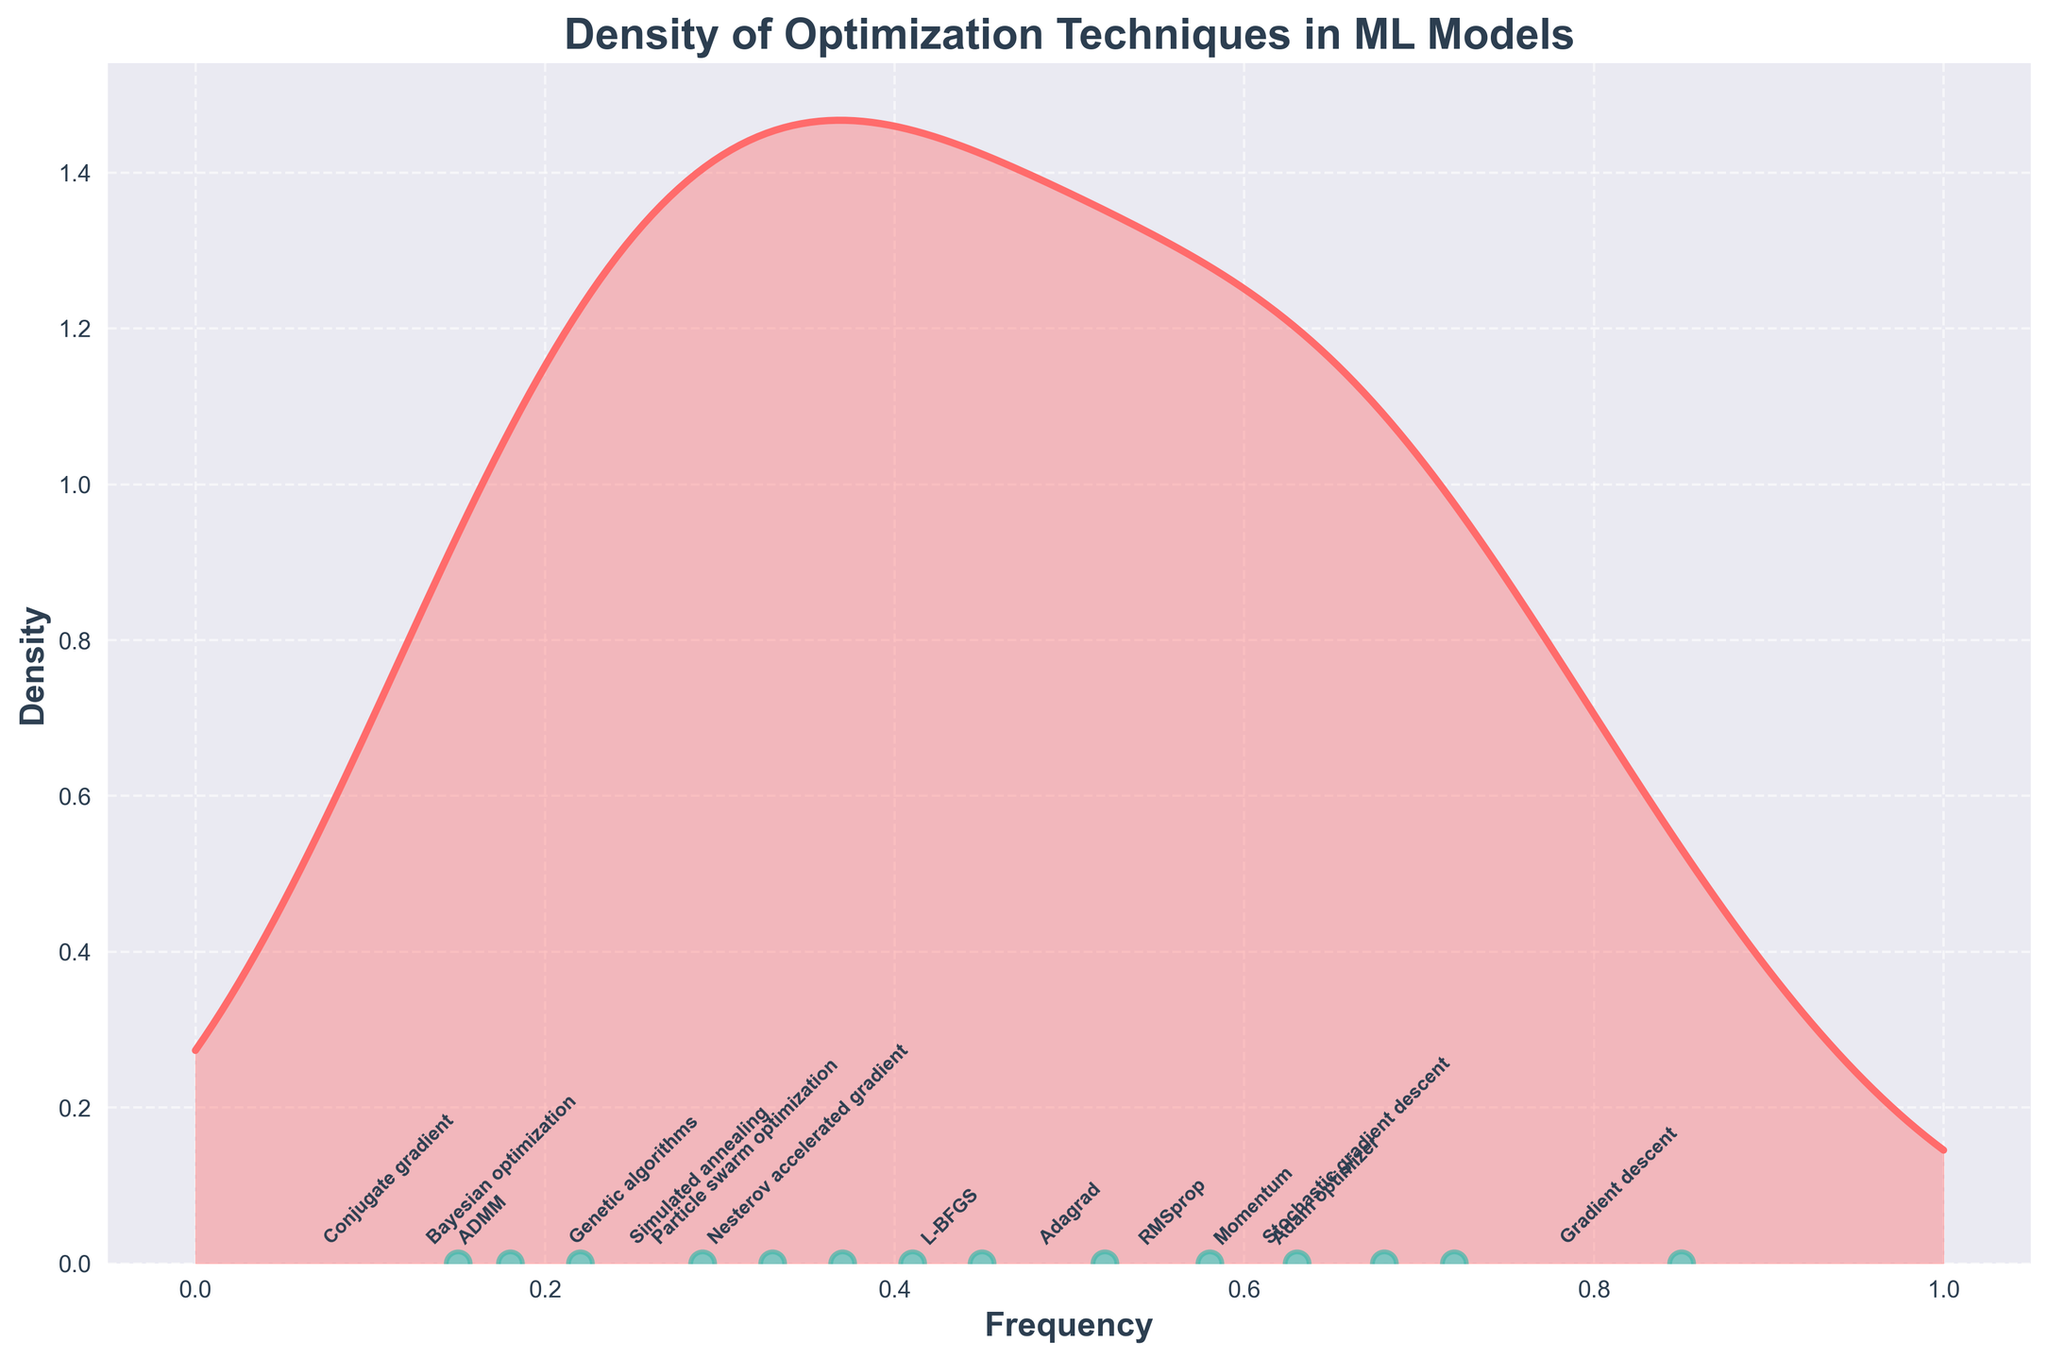What is the title of the figure? The title is written at the top of the figure, "Density of Optimization Techniques in ML Models".
Answer: "Density of Optimization Techniques in ML Models" Which optimization technique has the highest frequency? By observing the positions of scatter points along the x-axis, the point farthest to the right represents "Gradient descent" with a frequency of 0.85.
Answer: Gradient descent How many optimization techniques have a frequency higher than 0.6? Count the number of scatter points located to the right of the 0.6 mark on the x-axis. The techniques are "Gradient descent", "Stochastic gradient descent", and "Momentum".
Answer: 3 What is the frequency of Bayesian optimization? Locate the annotation for "Bayesian optimization" and observe its position along the x-axis. The frequency given is 0.22.
Answer: 0.22 Compare the frequency of Adam optimizer and RMSprop. Which one is higher and by how much? Find "Adam optimizer" and "RMSprop" on the figure. Adam optimizer has a frequency of 0.68, and RMSprop has a frequency of 0.58. Subtract RMSprop's frequency from Adam optimizer's.
Answer: Adam optimizer is higher by 0.1 Which domains apply Nesterov accelerated gradient and Particle swarm optimization techniques? From the figure, locate the annotations for "Nesterov accelerated gradient" and "Particle swarm optimization". Refer to the note for the domains associated with each technique.
Answer: Robotics and Image segmentation How does the frequency distribution's density change as the frequency increases from 0 to 1? Observe the shape of the density curve, noting whether it increases or decreases. The density is higher around mid-range frequencies and decreases toward the extremities.
Answer: Density is higher around mid-range frequencies and lower at the ends What is the frequency difference between the techniques applied in computer vision and game AI domains? Identify the frequencies of "Gradient descent" (0.85, Computer vision) and "Genetic algorithms" (0.29, Game AI), then find the difference.
Answer: 0.56 Which optimization technique has the lowest frequency, and in which domain is it applied? Locate the scatter point closest to the left side of the x-axis with the lowest frequency. This corresponds to "Conjugate gradient" with a frequency of 0.15 applied in Quantum computing.
Answer: Conjugate gradient, Quantum computing Is the frequency of Adagrad higher or lower than that of Simulated annealing? Locate the positions of "Adagrad" and "Simulated annealing" on the x-axis. Adagrad has a frequency of 0.52, and Simulated annealing has a frequency of 0.33.
Answer: Higher 